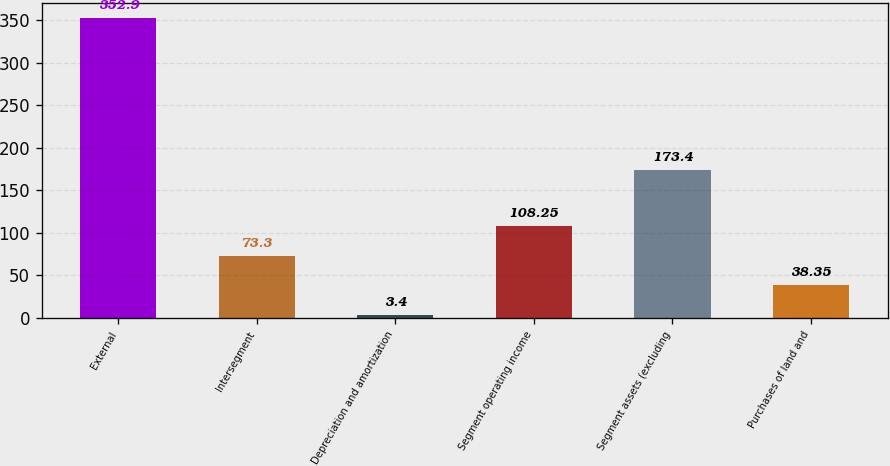Convert chart to OTSL. <chart><loc_0><loc_0><loc_500><loc_500><bar_chart><fcel>External<fcel>Intersegment<fcel>Depreciation and amortization<fcel>Segment operating income<fcel>Segment assets (excluding<fcel>Purchases of land and<nl><fcel>352.9<fcel>73.3<fcel>3.4<fcel>108.25<fcel>173.4<fcel>38.35<nl></chart> 